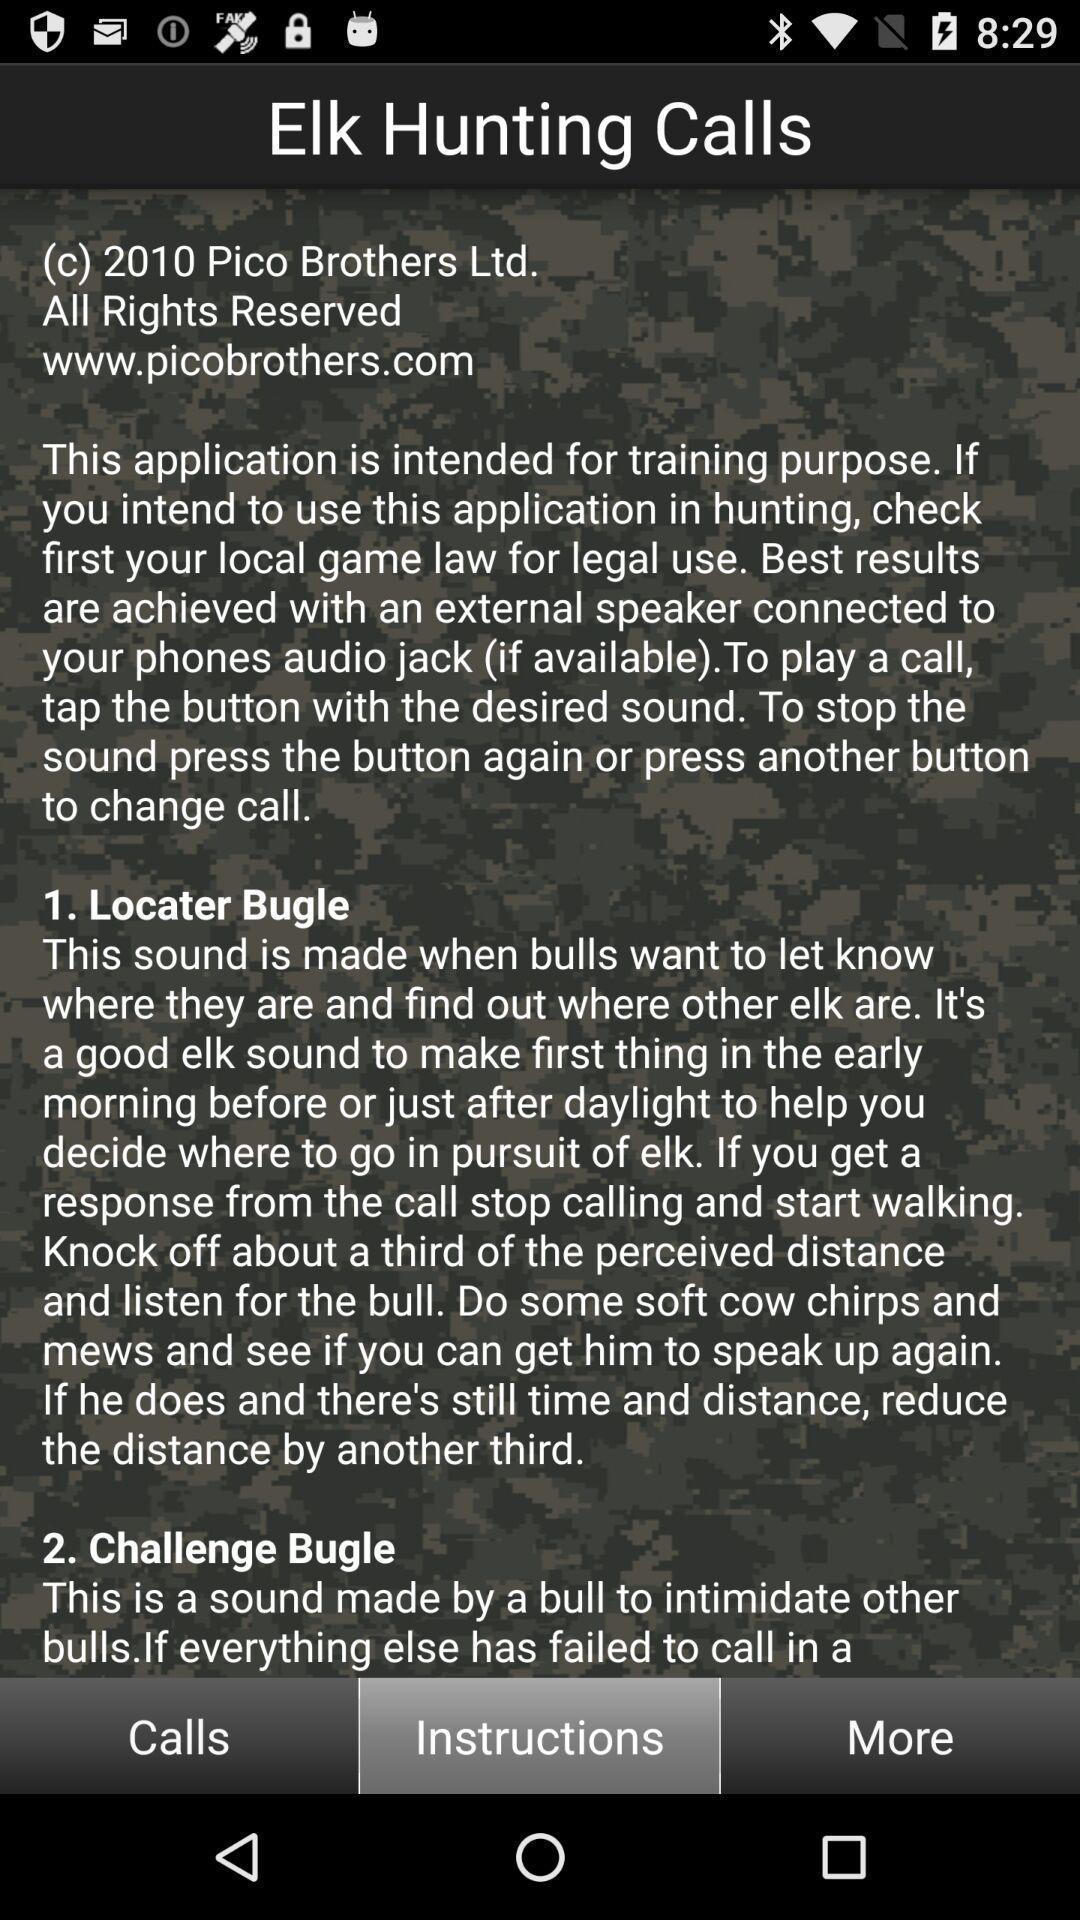Tell me about the visual elements in this screen capture. Page displaying the learning app. 